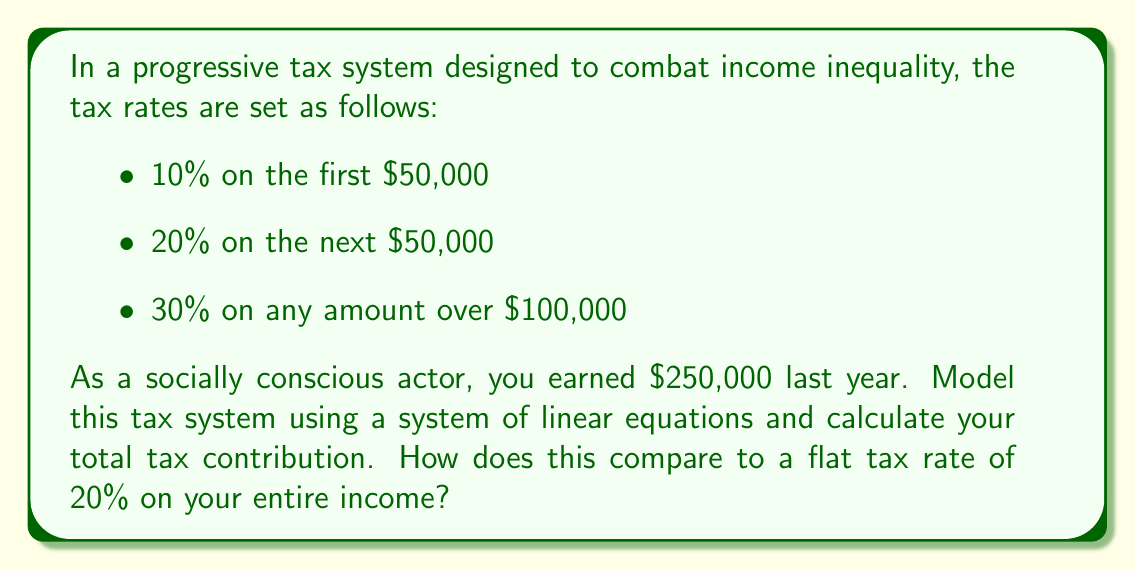Help me with this question. Let's approach this step-by-step:

1) First, we'll set up our system of linear equations:
   Let $x_1$ be the tax on the first $50,000
   Let $x_2$ be the tax on the next $50,000
   Let $x_3$ be the tax on the remaining $150,000

   Our system of equations:
   $$\begin{cases}
   x_1 = 0.10 \cdot 50000 \\
   x_2 = 0.20 \cdot 50000 \\
   x_3 = 0.30 \cdot 150000
   \end{cases}$$

2) Solve the system:
   $$\begin{cases}
   x_1 = 5000 \\
   x_2 = 10000 \\
   x_3 = 45000
   \end{cases}$$

3) Calculate total tax:
   $$\text{Total Tax} = x_1 + x_2 + x_3 = 5000 + 10000 + 45000 = 60000$$

4) Calculate effective tax rate:
   $$\text{Effective Rate} = \frac{60000}{250000} \cdot 100\% = 24\%$$

5) Compare to flat tax:
   Flat tax would be: $250000 \cdot 0.20 = 50000$

The progressive system results in $10,000 more in taxes, demonstrating how it places a higher burden on higher incomes to address inequality.
Answer: $60,000 in progressive tax; $10,000 more than flat tax 